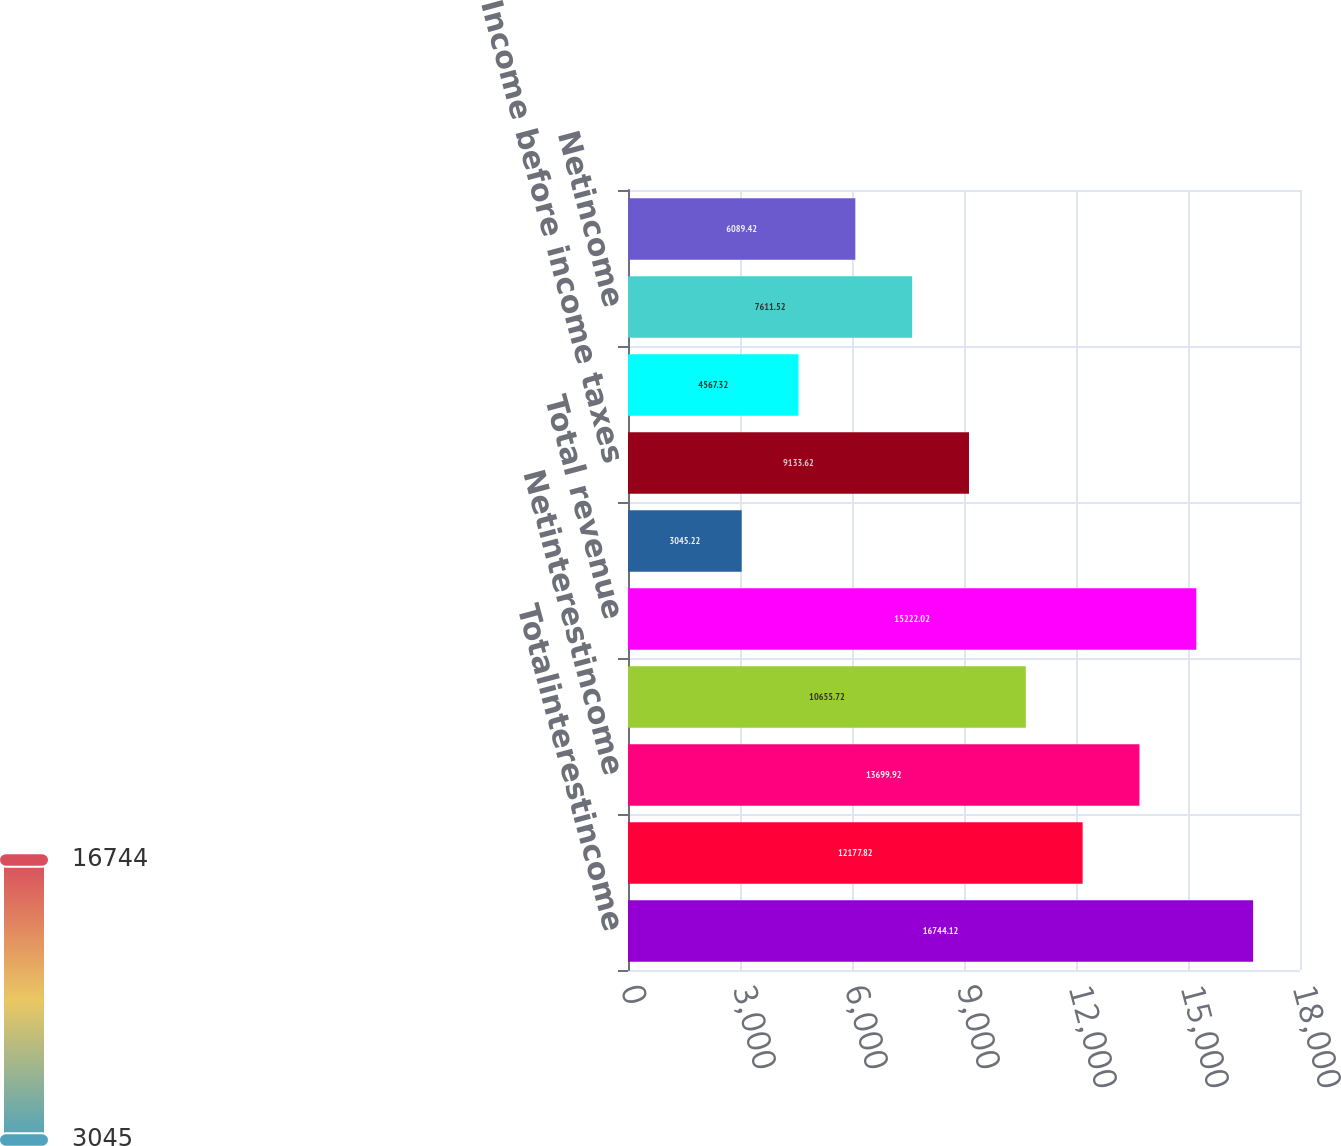Convert chart to OTSL. <chart><loc_0><loc_0><loc_500><loc_500><bar_chart><fcel>Totalinterestincome<fcel>Total interest expense<fcel>Netinterestincome<fcel>Total noninterest income<fcel>Total revenue<fcel>Gains on sales of debt<fcel>Income before income taxes<fcel>Income tax expense<fcel>Netincome<fcel>Net income available to common<nl><fcel>16744.1<fcel>12177.8<fcel>13699.9<fcel>10655.7<fcel>15222<fcel>3045.22<fcel>9133.62<fcel>4567.32<fcel>7611.52<fcel>6089.42<nl></chart> 